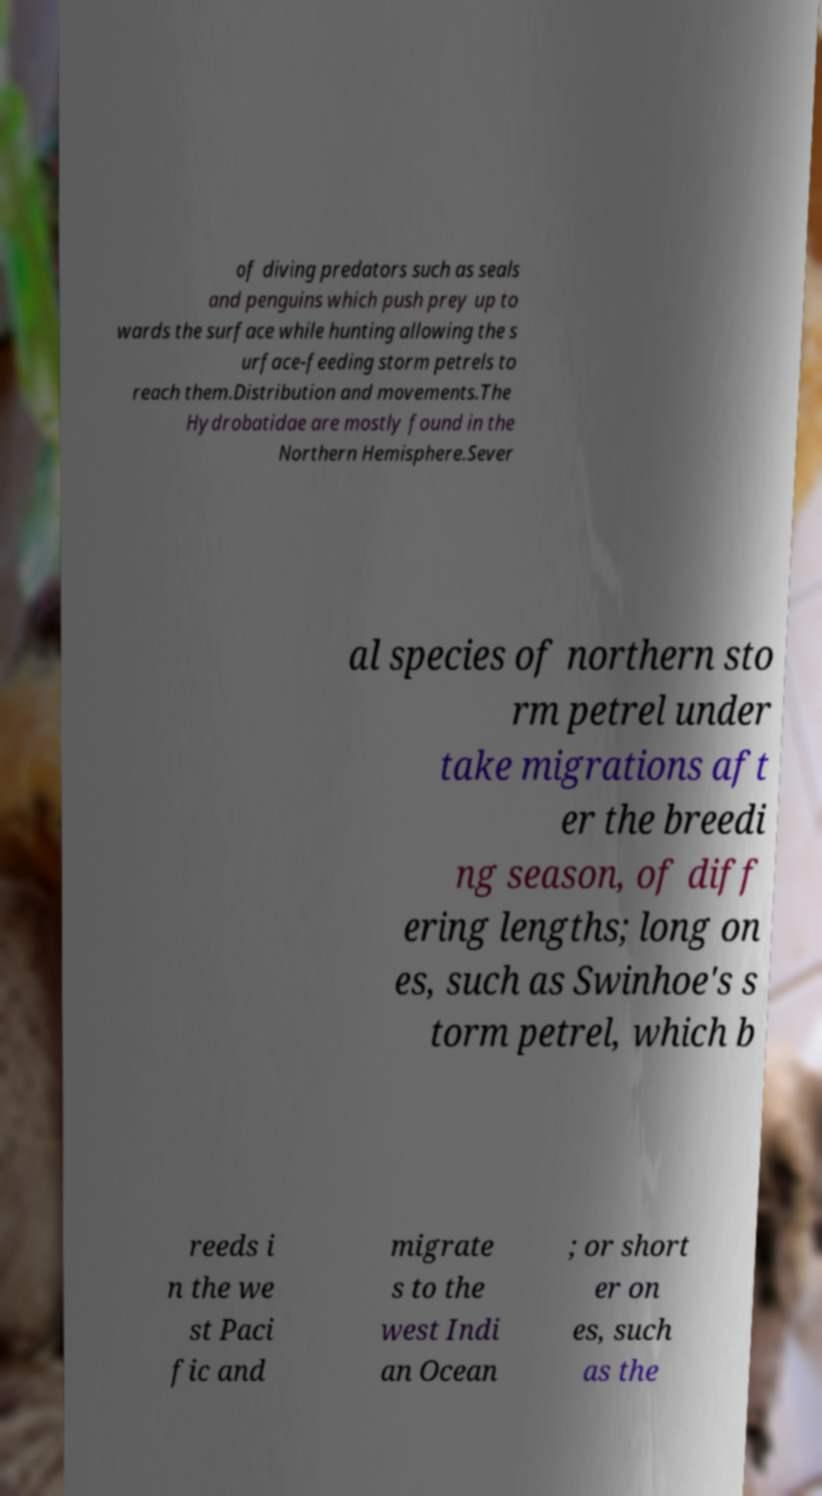Could you assist in decoding the text presented in this image and type it out clearly? of diving predators such as seals and penguins which push prey up to wards the surface while hunting allowing the s urface-feeding storm petrels to reach them.Distribution and movements.The Hydrobatidae are mostly found in the Northern Hemisphere.Sever al species of northern sto rm petrel under take migrations aft er the breedi ng season, of diff ering lengths; long on es, such as Swinhoe's s torm petrel, which b reeds i n the we st Paci fic and migrate s to the west Indi an Ocean ; or short er on es, such as the 